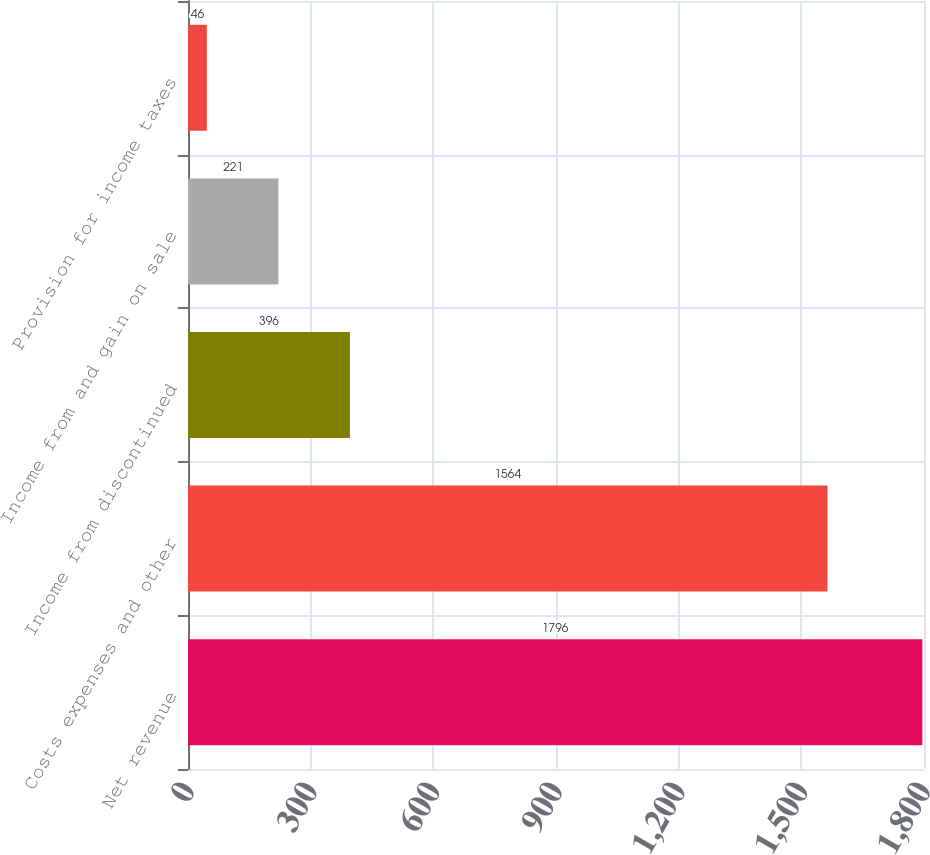Convert chart to OTSL. <chart><loc_0><loc_0><loc_500><loc_500><bar_chart><fcel>Net revenue<fcel>Costs expenses and other<fcel>Income from discontinued<fcel>Income from and gain on sale<fcel>Provision for income taxes<nl><fcel>1796<fcel>1564<fcel>396<fcel>221<fcel>46<nl></chart> 